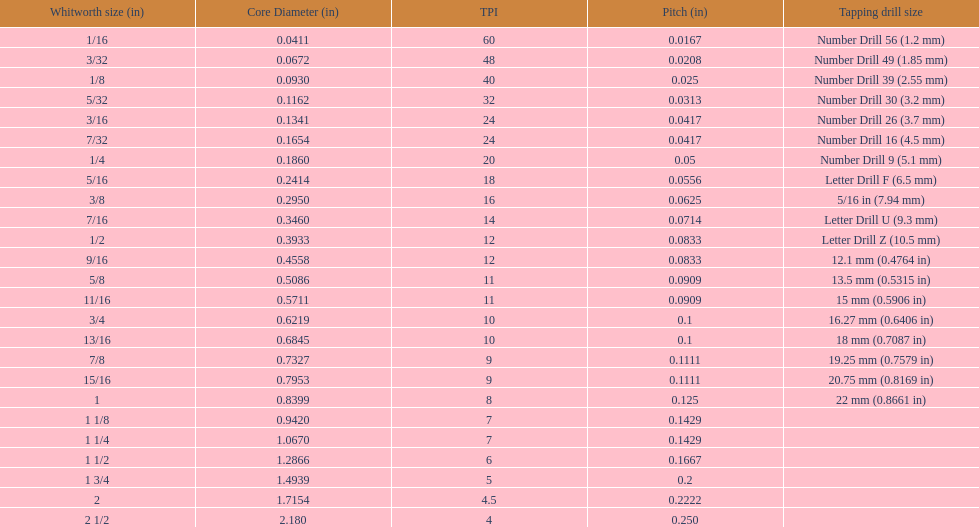Which whitworth size is the only one with 5 threads per inch? 1 3/4. 